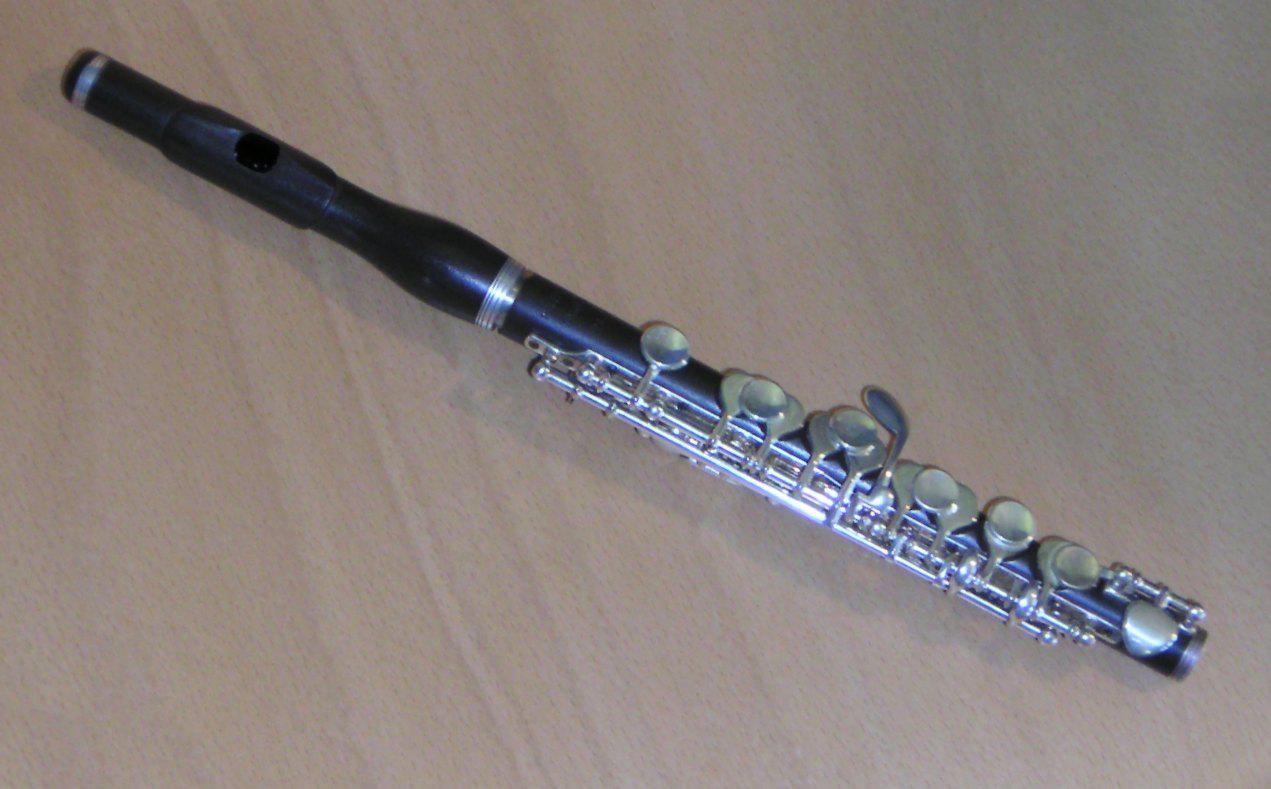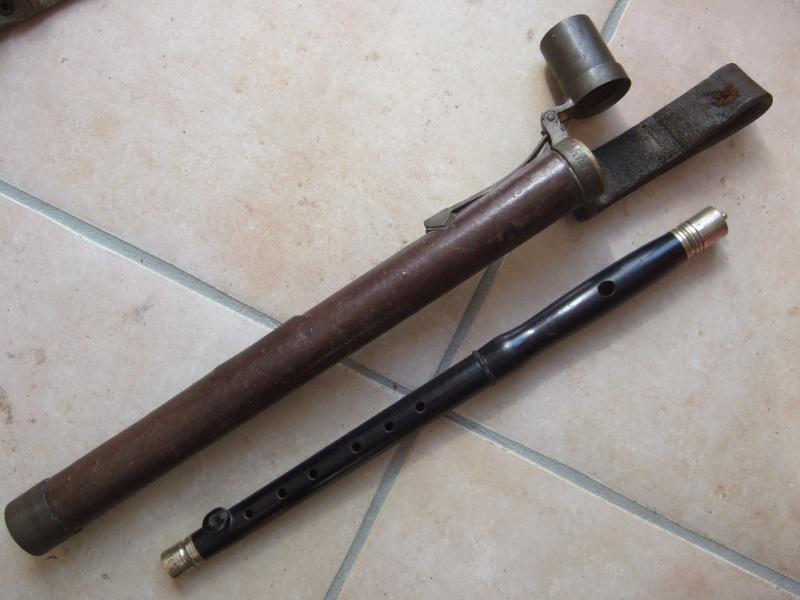The first image is the image on the left, the second image is the image on the right. Analyze the images presented: Is the assertion "The left image contains a single flute displayed at an angle, and the right image includes one flute displayed at an angle opposite that of the flute on the left." valid? Answer yes or no. Yes. 